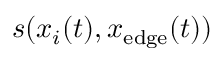Convert formula to latex. <formula><loc_0><loc_0><loc_500><loc_500>s ( x _ { i } ( t ) , x _ { e d g e } ( t ) )</formula> 